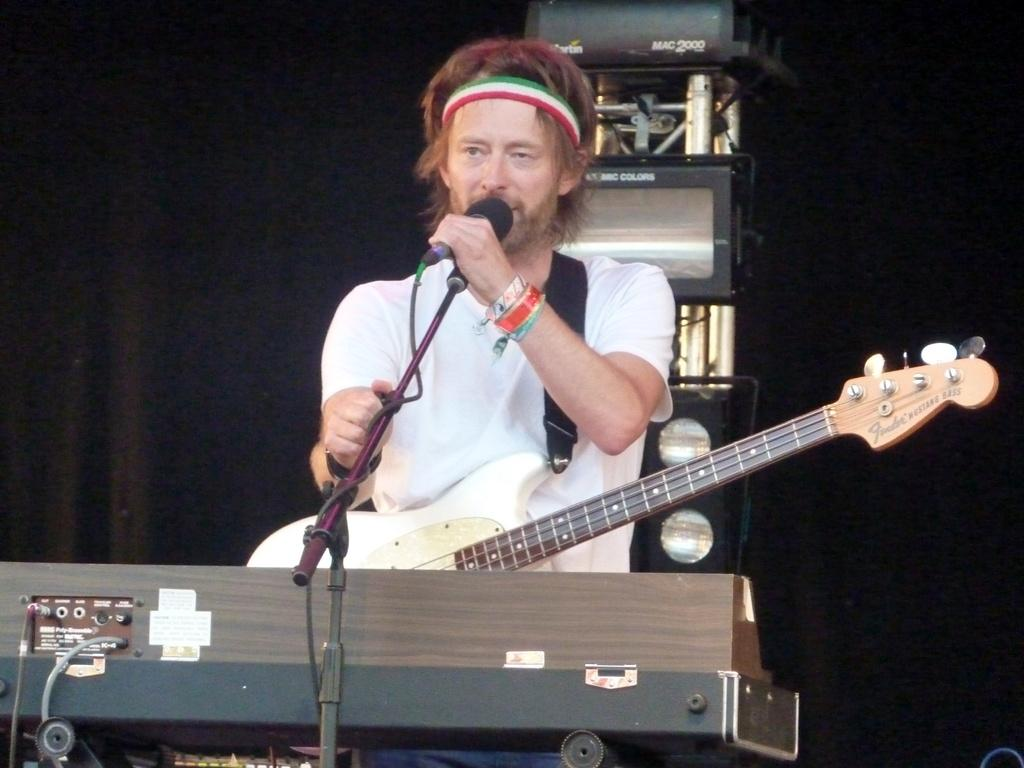What is the man in the image holding? The man has a guitar and is holding a microphone. What is in front of the man? There is a keyboard in front of the man. What is the man doing in the image? The man is singing something. What is the man wearing? The man is wearing a white T-shirt. What type of animal is the man paying with a needle in the image? There is no animal, payment, or needle present in the image. 